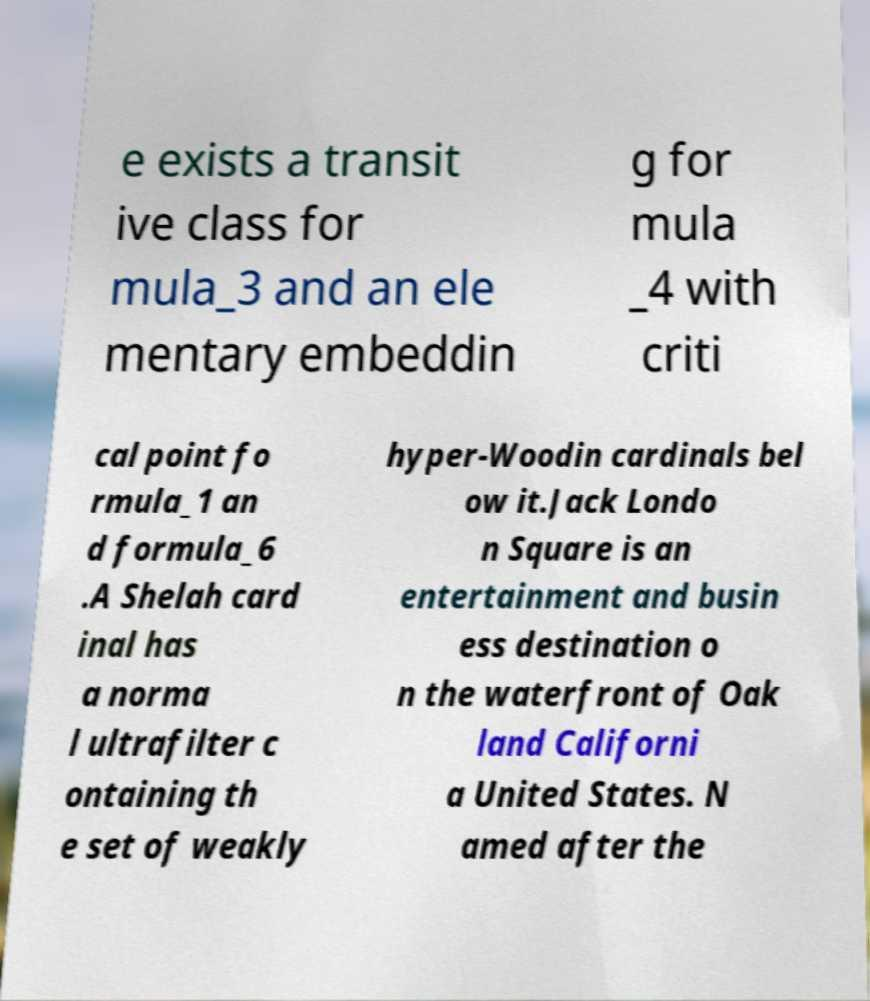Could you assist in decoding the text presented in this image and type it out clearly? e exists a transit ive class for mula_3 and an ele mentary embeddin g for mula _4 with criti cal point fo rmula_1 an d formula_6 .A Shelah card inal has a norma l ultrafilter c ontaining th e set of weakly hyper-Woodin cardinals bel ow it.Jack Londo n Square is an entertainment and busin ess destination o n the waterfront of Oak land Californi a United States. N amed after the 